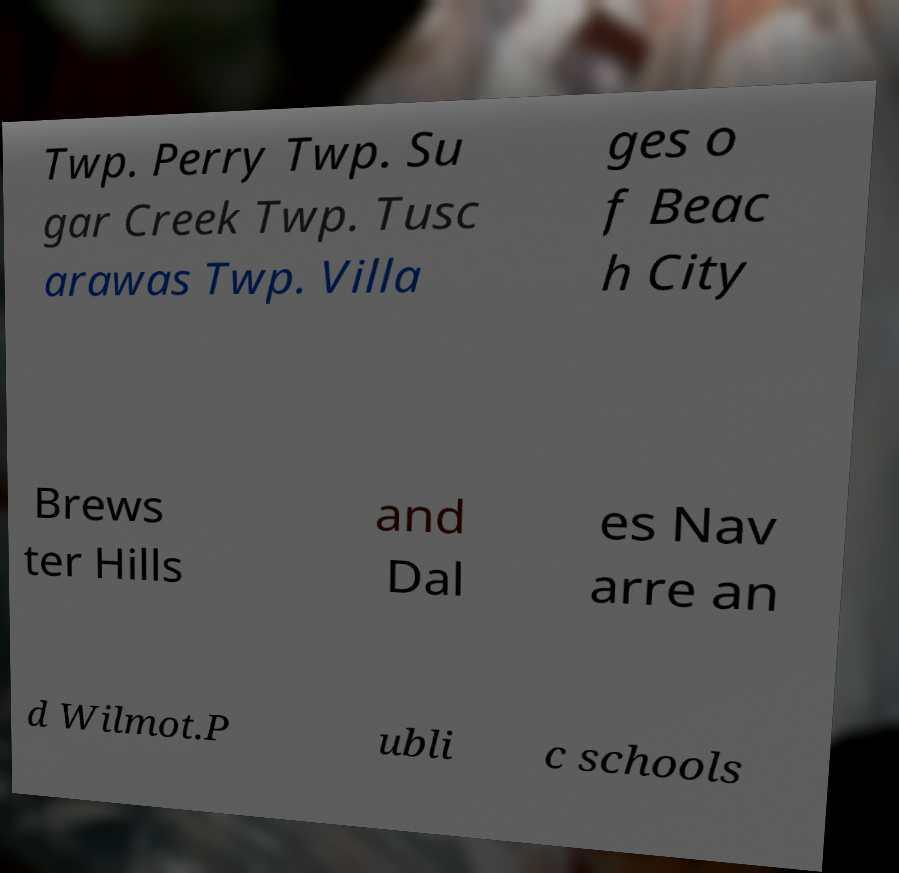For documentation purposes, I need the text within this image transcribed. Could you provide that? Twp. Perry Twp. Su gar Creek Twp. Tusc arawas Twp. Villa ges o f Beac h City Brews ter Hills and Dal es Nav arre an d Wilmot.P ubli c schools 